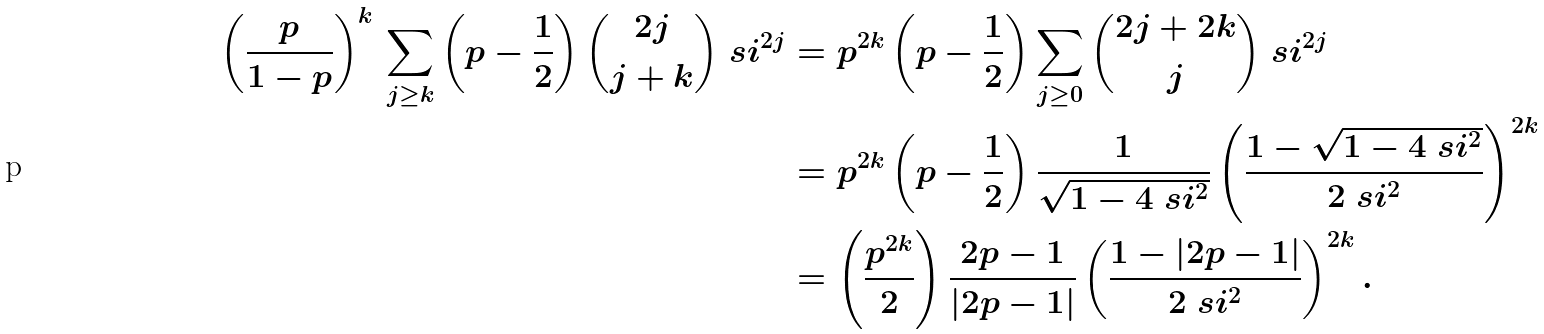<formula> <loc_0><loc_0><loc_500><loc_500>\left ( \frac { p } { 1 - p } \right ) ^ { k } \, \sum _ { j \geq k } \left ( p - \frac { 1 } { 2 } \right ) \binom { 2 j } { j + k } \ s i ^ { 2 j } & = p ^ { 2 k } \left ( p - \frac { 1 } { 2 } \right ) \sum _ { j \geq 0 } \binom { 2 j + 2 k } { j } \ s i ^ { 2 j } \\ & = p ^ { 2 k } \left ( p - \frac { 1 } { 2 } \right ) \frac { 1 } { \sqrt { 1 - 4 \ s i ^ { 2 } } } \left ( \frac { 1 - \sqrt { 1 - 4 \ s i ^ { 2 } } } { 2 \ s i ^ { 2 } } \right ) ^ { 2 k } \\ & = \left ( \frac { p ^ { 2 k } } { 2 } \right ) \frac { 2 p - 1 } { | 2 p - 1 | } \left ( \frac { 1 - | 2 p - 1 | } { 2 \ s i ^ { 2 } } \right ) ^ { 2 k } .</formula> 